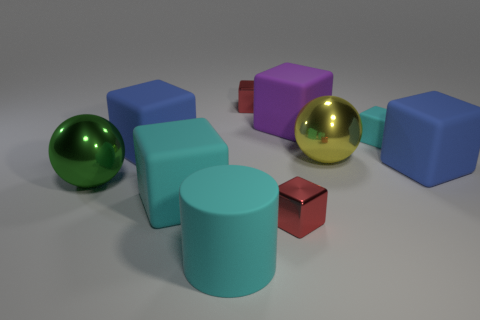Subtract all tiny red cubes. How many cubes are left? 5 Subtract all green cylinders. How many blue blocks are left? 2 Subtract all red cubes. How many cubes are left? 5 Subtract all cubes. How many objects are left? 3 Subtract 3 blocks. How many blocks are left? 4 Add 2 big cyan rubber spheres. How many big cyan rubber spheres exist? 2 Subtract 2 blue blocks. How many objects are left? 8 Subtract all purple cylinders. Subtract all yellow spheres. How many cylinders are left? 1 Subtract all big cyan metal cylinders. Subtract all blue matte cubes. How many objects are left? 8 Add 4 metallic things. How many metallic things are left? 8 